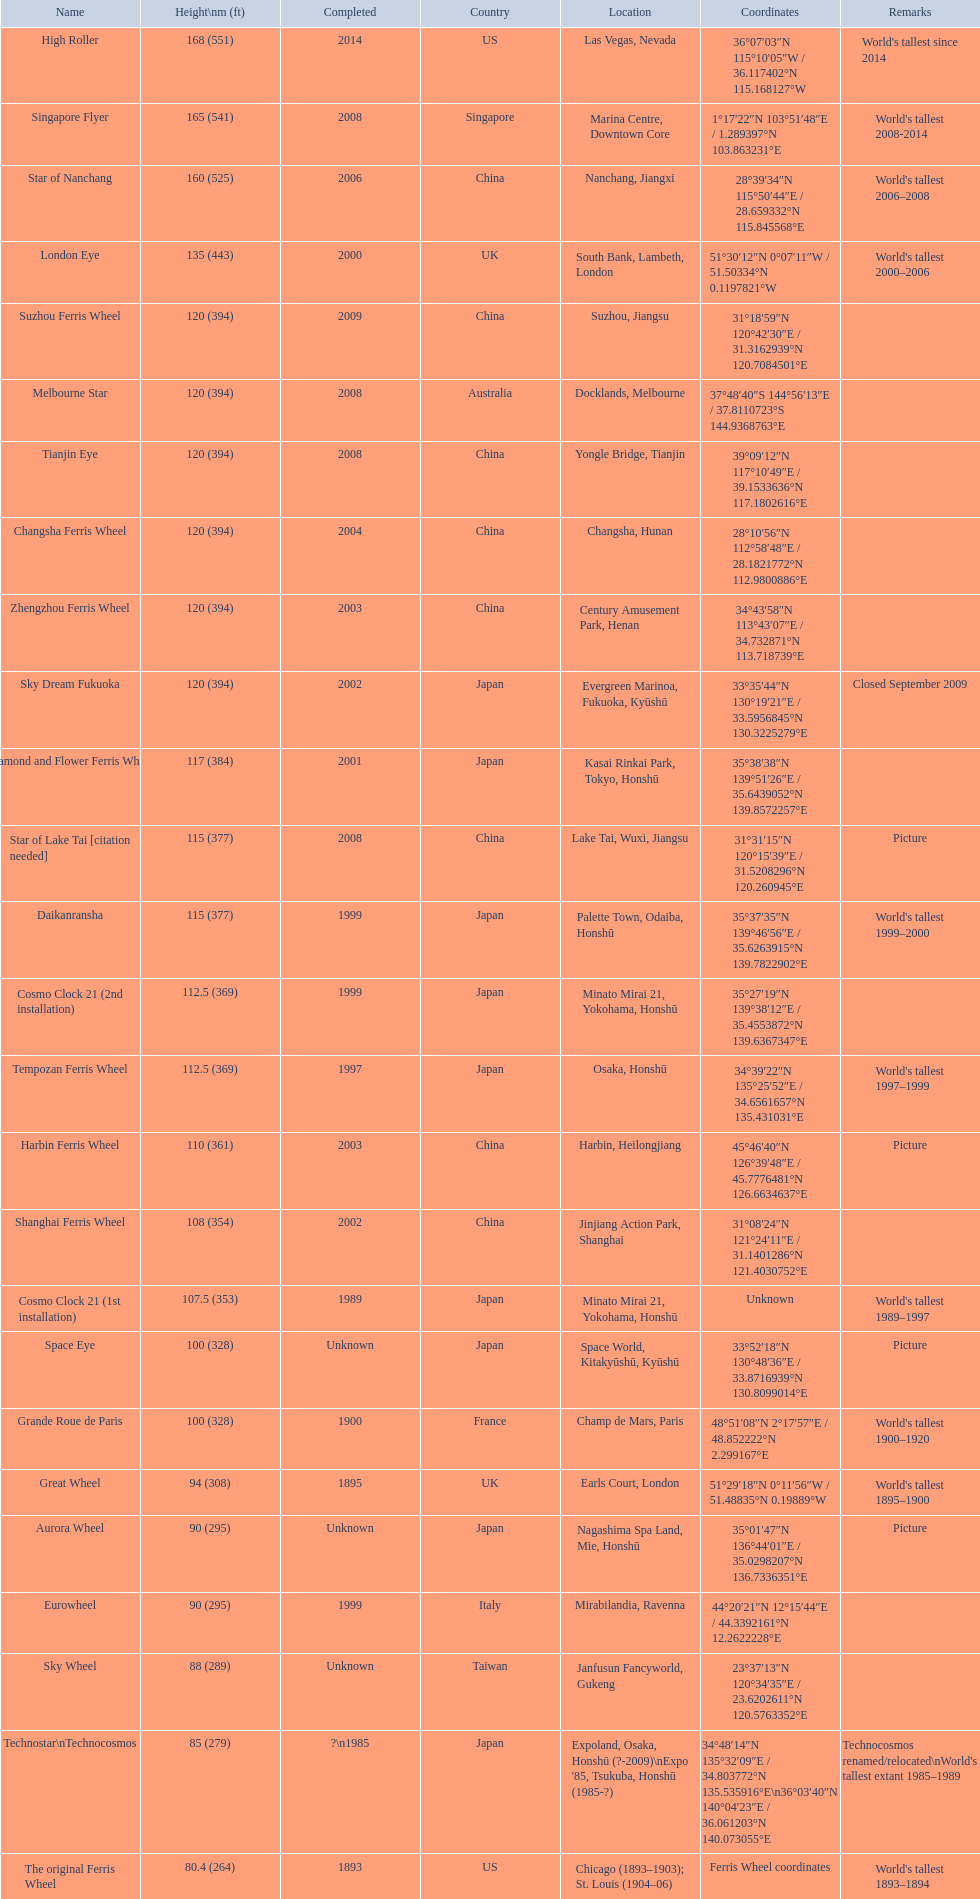What are the distinct finishing dates for the ferris wheel list? 2014, 2008, 2006, 2000, 2009, 2008, 2008, 2004, 2003, 2002, 2001, 2008, 1999, 1999, 1997, 2003, 2002, 1989, Unknown, 1900, 1895, Unknown, 1999, Unknown, ?\n1985, 1893. Which dates for the star of lake tai, star of nanchang, melbourne star? 2006, 2008, 2008. Which is the eldest? 2006. What is the title of this ride? Star of Nanchang. 